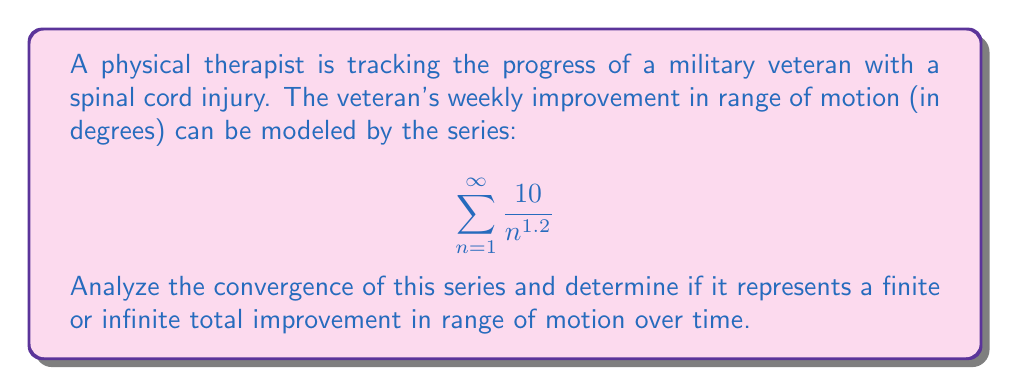Could you help me with this problem? To analyze the convergence of this series, we'll use the p-series test:

1) The general form of a p-series is:
   $$\sum_{n=1}^{\infty} \frac{1}{n^p}$$

2) Our series can be rewritten as:
   $$10 \sum_{n=1}^{\infty} \frac{1}{n^{1.2}}$$

3) The constant 10 doesn't affect convergence, so we focus on:
   $$\sum_{n=1}^{\infty} \frac{1}{n^{1.2}}$$

4) For a p-series:
   - If $p > 1$, the series converges
   - If $p \leq 1$, the series diverges

5) In our case, $p = 1.2$

6) Since $1.2 > 1$, the series converges

7) A converging series implies a finite sum, meaning the total improvement in range of motion over time is finite.
Answer: The series converges, representing a finite total improvement. 